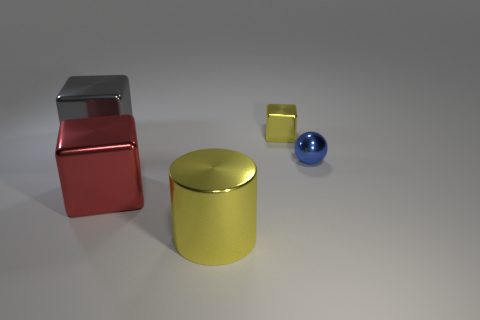Add 3 rubber cylinders. How many objects exist? 8 Subtract all large blocks. How many blocks are left? 1 Subtract all cylinders. How many objects are left? 4 Add 2 tiny blue balls. How many tiny blue balls are left? 3 Add 1 cyan shiny blocks. How many cyan shiny blocks exist? 1 Subtract 0 blue cylinders. How many objects are left? 5 Subtract all cyan cubes. Subtract all gray balls. How many cubes are left? 3 Subtract all cylinders. Subtract all small yellow shiny blocks. How many objects are left? 3 